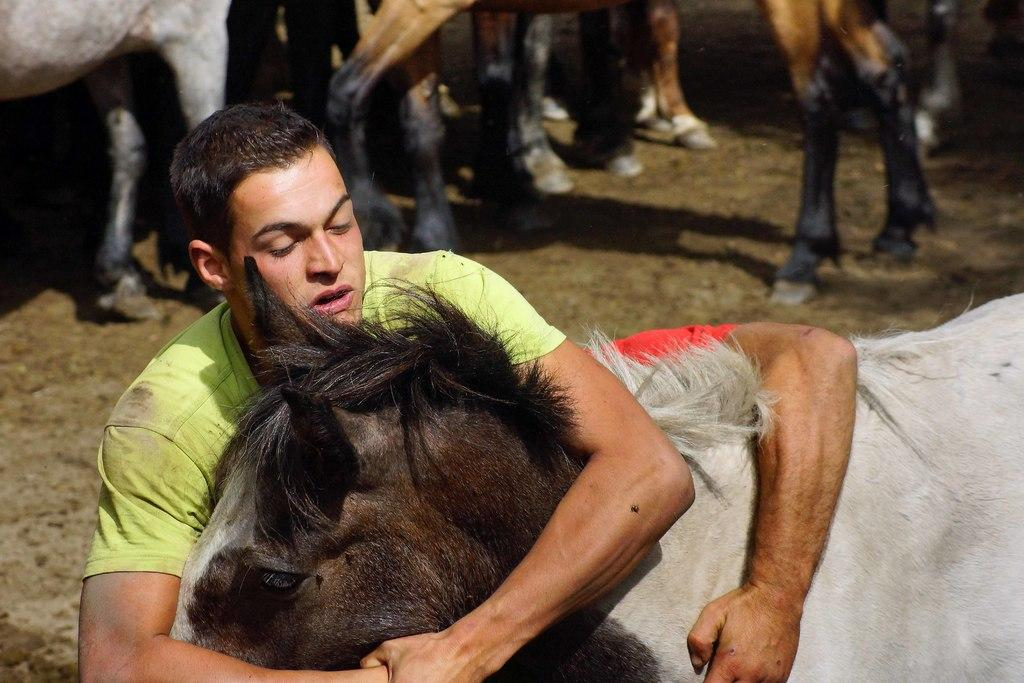What is the main subject of the image? The main subject of the image is a man. What is the man wearing in the image? The man is wearing a green t-shirt in the image. What is the man doing with his hands in the image? The man is holding an animal with his hands in the image. Can you describe the background of the image? There are animal legs visible in the background of the image. How does the man guide the playground in the image? There is no playground present in the image, so the man cannot guide it. 